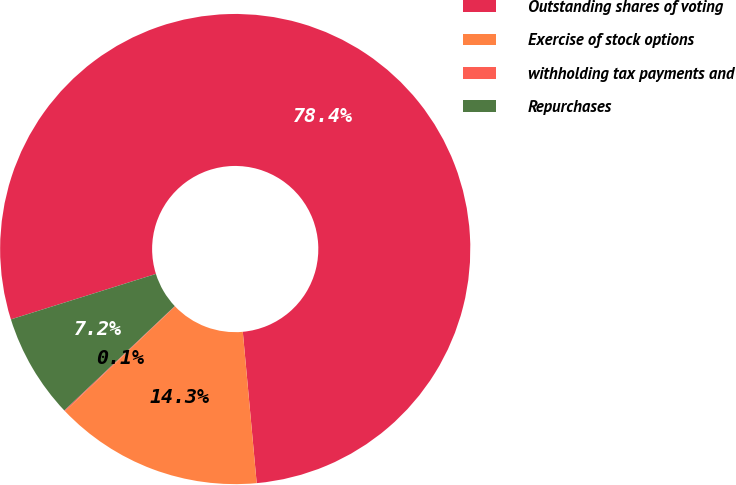<chart> <loc_0><loc_0><loc_500><loc_500><pie_chart><fcel>Outstanding shares of voting<fcel>Exercise of stock options<fcel>withholding tax payments and<fcel>Repurchases<nl><fcel>78.38%<fcel>14.34%<fcel>0.07%<fcel>7.21%<nl></chart> 